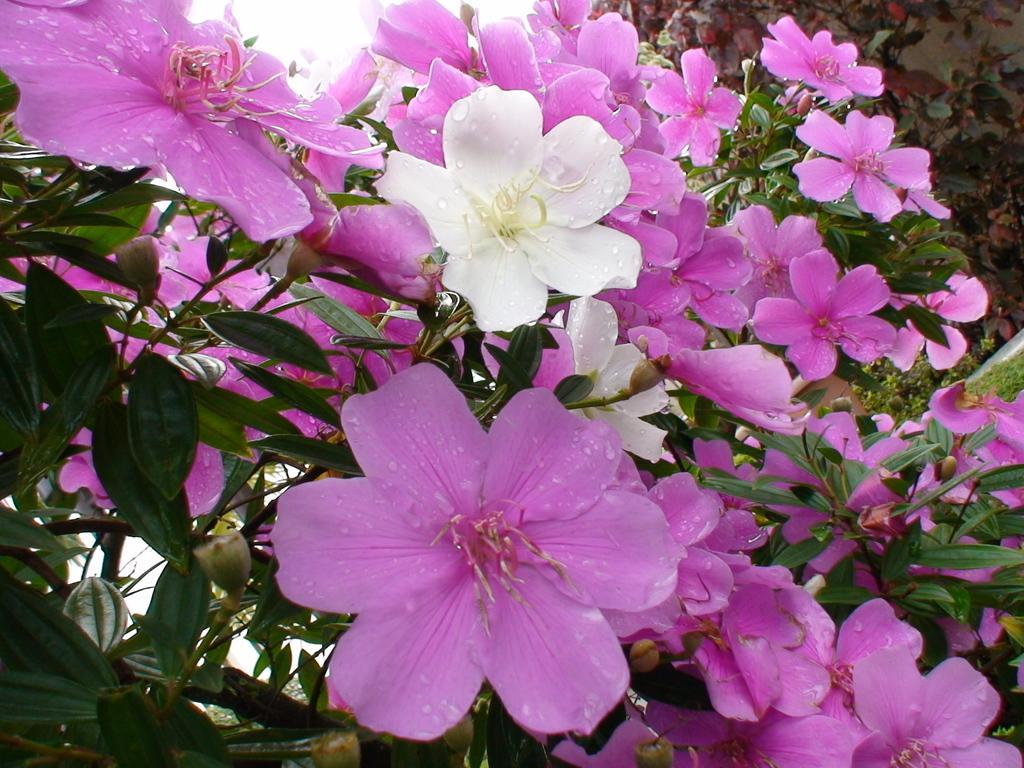Describe this image in one or two sentences. In this image there are pink and white color flowers on the plants and there are water drops on the flowers. At the top there is sky. 